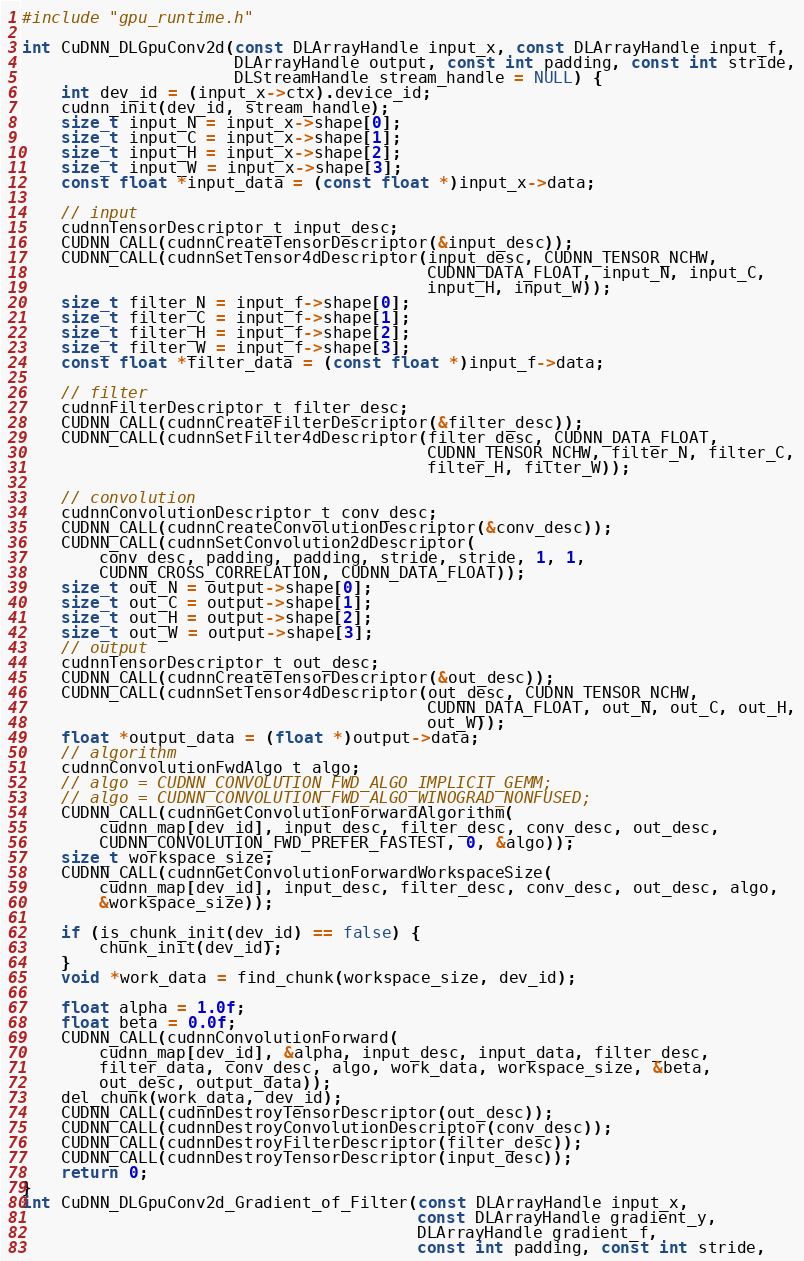<code> <loc_0><loc_0><loc_500><loc_500><_Cuda_>#include "gpu_runtime.h"

int CuDNN_DLGpuConv2d(const DLArrayHandle input_x, const DLArrayHandle input_f,
                      DLArrayHandle output, const int padding, const int stride,
                      DLStreamHandle stream_handle = NULL) {
    int dev_id = (input_x->ctx).device_id;
    cudnn_init(dev_id, stream_handle);
    size_t input_N = input_x->shape[0];
    size_t input_C = input_x->shape[1];
    size_t input_H = input_x->shape[2];
    size_t input_W = input_x->shape[3];
    const float *input_data = (const float *)input_x->data;

    // input
    cudnnTensorDescriptor_t input_desc;
    CUDNN_CALL(cudnnCreateTensorDescriptor(&input_desc));
    CUDNN_CALL(cudnnSetTensor4dDescriptor(input_desc, CUDNN_TENSOR_NCHW,
                                          CUDNN_DATA_FLOAT, input_N, input_C,
                                          input_H, input_W));
    size_t filter_N = input_f->shape[0];
    size_t filter_C = input_f->shape[1];
    size_t filter_H = input_f->shape[2];
    size_t filter_W = input_f->shape[3];
    const float *filter_data = (const float *)input_f->data;

    // filter
    cudnnFilterDescriptor_t filter_desc;
    CUDNN_CALL(cudnnCreateFilterDescriptor(&filter_desc));
    CUDNN_CALL(cudnnSetFilter4dDescriptor(filter_desc, CUDNN_DATA_FLOAT,
                                          CUDNN_TENSOR_NCHW, filter_N, filter_C,
                                          filter_H, filter_W));

    // convolution
    cudnnConvolutionDescriptor_t conv_desc;
    CUDNN_CALL(cudnnCreateConvolutionDescriptor(&conv_desc));
    CUDNN_CALL(cudnnSetConvolution2dDescriptor(
        conv_desc, padding, padding, stride, stride, 1, 1,
        CUDNN_CROSS_CORRELATION, CUDNN_DATA_FLOAT));
    size_t out_N = output->shape[0];
    size_t out_C = output->shape[1];
    size_t out_H = output->shape[2];
    size_t out_W = output->shape[3];
    // output
    cudnnTensorDescriptor_t out_desc;
    CUDNN_CALL(cudnnCreateTensorDescriptor(&out_desc));
    CUDNN_CALL(cudnnSetTensor4dDescriptor(out_desc, CUDNN_TENSOR_NCHW,
                                          CUDNN_DATA_FLOAT, out_N, out_C, out_H,
                                          out_W));
    float *output_data = (float *)output->data;
    // algorithm
    cudnnConvolutionFwdAlgo_t algo;
    // algo = CUDNN_CONVOLUTION_FWD_ALGO_IMPLICIT_GEMM;
    // algo = CUDNN_CONVOLUTION_FWD_ALGO_WINOGRAD_NONFUSED;
    CUDNN_CALL(cudnnGetConvolutionForwardAlgorithm(
        cudnn_map[dev_id], input_desc, filter_desc, conv_desc, out_desc,
        CUDNN_CONVOLUTION_FWD_PREFER_FASTEST, 0, &algo));
    size_t workspace_size;
    CUDNN_CALL(cudnnGetConvolutionForwardWorkspaceSize(
        cudnn_map[dev_id], input_desc, filter_desc, conv_desc, out_desc, algo,
        &workspace_size));

    if (is_chunk_init(dev_id) == false) {
        chunk_init(dev_id);
    }
    void *work_data = find_chunk(workspace_size, dev_id);

    float alpha = 1.0f;
    float beta = 0.0f;
    CUDNN_CALL(cudnnConvolutionForward(
        cudnn_map[dev_id], &alpha, input_desc, input_data, filter_desc,
        filter_data, conv_desc, algo, work_data, workspace_size, &beta,
        out_desc, output_data));
    del_chunk(work_data, dev_id);
    CUDNN_CALL(cudnnDestroyTensorDescriptor(out_desc));
    CUDNN_CALL(cudnnDestroyConvolutionDescriptor(conv_desc));
    CUDNN_CALL(cudnnDestroyFilterDescriptor(filter_desc));
    CUDNN_CALL(cudnnDestroyTensorDescriptor(input_desc));
    return 0;
}
int CuDNN_DLGpuConv2d_Gradient_of_Filter(const DLArrayHandle input_x,
                                         const DLArrayHandle gradient_y,
                                         DLArrayHandle gradient_f,
                                         const int padding, const int stride,</code> 